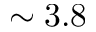Convert formula to latex. <formula><loc_0><loc_0><loc_500><loc_500>\sim 3 . 8</formula> 